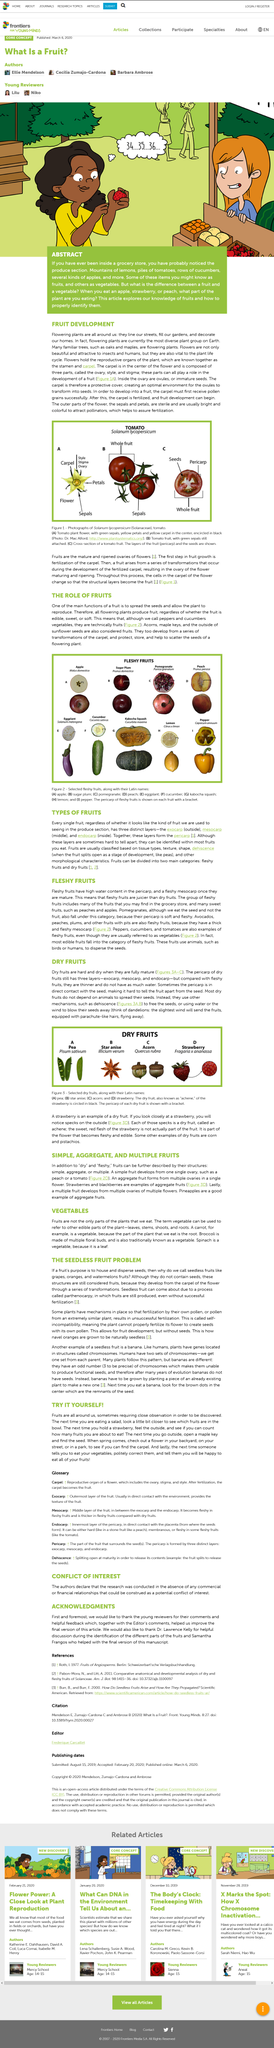Give some essential details in this illustration. The definition of a fruit is the mature and ripened ovaries of flowers, which are the ripened ovules that contain the female reproductive cells of a plant. Mechanisms used by fruit to spread their seeds include dehiscence. Dry fruit has three layers. Acorns are considered fruits. Yes, they are. The banana has three chromosomes. 